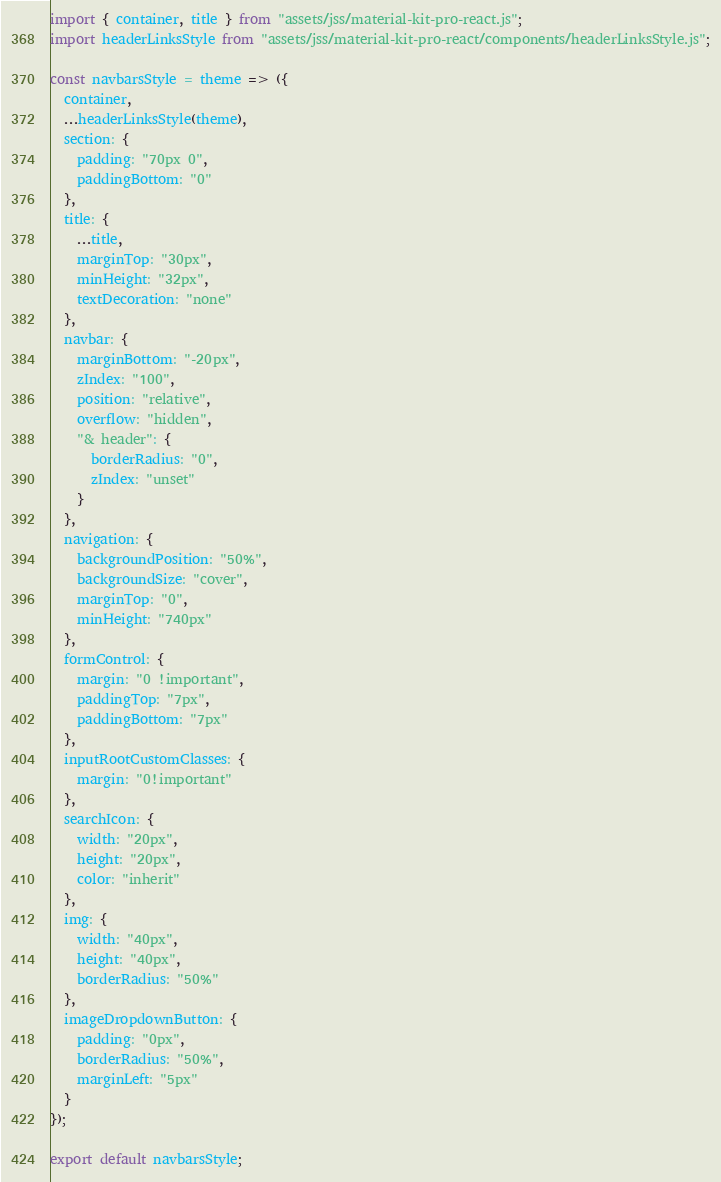<code> <loc_0><loc_0><loc_500><loc_500><_JavaScript_>import { container, title } from "assets/jss/material-kit-pro-react.js";
import headerLinksStyle from "assets/jss/material-kit-pro-react/components/headerLinksStyle.js";

const navbarsStyle = theme => ({
  container,
  ...headerLinksStyle(theme),
  section: {
    padding: "70px 0",
    paddingBottom: "0"
  },
  title: {
    ...title,
    marginTop: "30px",
    minHeight: "32px",
    textDecoration: "none"
  },
  navbar: {
    marginBottom: "-20px",
    zIndex: "100",
    position: "relative",
    overflow: "hidden",
    "& header": {
      borderRadius: "0",
      zIndex: "unset"
    }
  },
  navigation: {
    backgroundPosition: "50%",
    backgroundSize: "cover",
    marginTop: "0",
    minHeight: "740px"
  },
  formControl: {
    margin: "0 !important",
    paddingTop: "7px",
    paddingBottom: "7px"
  },
  inputRootCustomClasses: {
    margin: "0!important"
  },
  searchIcon: {
    width: "20px",
    height: "20px",
    color: "inherit"
  },
  img: {
    width: "40px",
    height: "40px",
    borderRadius: "50%"
  },
  imageDropdownButton: {
    padding: "0px",
    borderRadius: "50%",
    marginLeft: "5px"
  }
});

export default navbarsStyle;
</code> 